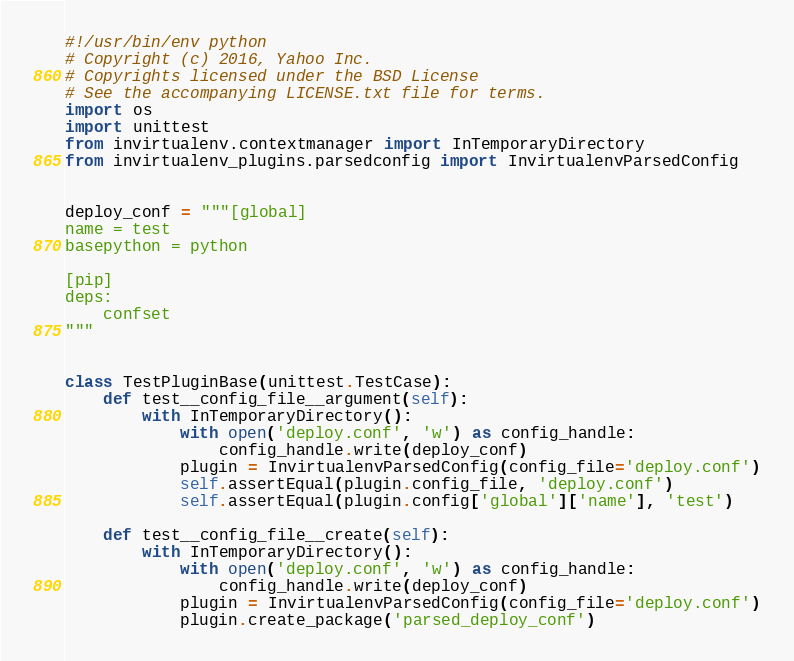<code> <loc_0><loc_0><loc_500><loc_500><_Python_>#!/usr/bin/env python
# Copyright (c) 2016, Yahoo Inc.
# Copyrights licensed under the BSD License
# See the accompanying LICENSE.txt file for terms.
import os
import unittest
from invirtualenv.contextmanager import InTemporaryDirectory
from invirtualenv_plugins.parsedconfig import InvirtualenvParsedConfig


deploy_conf = """[global]
name = test
basepython = python

[pip]
deps:
    confset
"""


class TestPluginBase(unittest.TestCase):
    def test__config_file__argument(self):
        with InTemporaryDirectory():
            with open('deploy.conf', 'w') as config_handle:
                config_handle.write(deploy_conf)
            plugin = InvirtualenvParsedConfig(config_file='deploy.conf')
            self.assertEqual(plugin.config_file, 'deploy.conf')
            self.assertEqual(plugin.config['global']['name'], 'test')

    def test__config_file__create(self):
        with InTemporaryDirectory():
            with open('deploy.conf', 'w') as config_handle:
                config_handle.write(deploy_conf)
            plugin = InvirtualenvParsedConfig(config_file='deploy.conf')
            plugin.create_package('parsed_deploy_conf')
</code> 